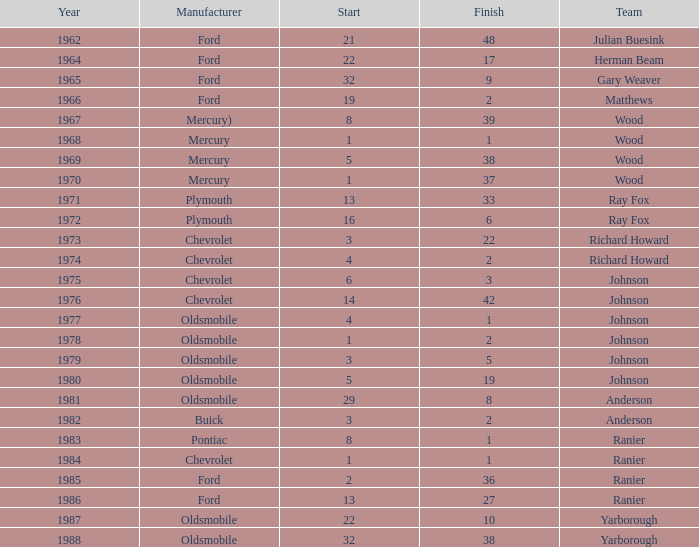What is the smallest finish time for a race after 1972 with a car manufactured by pontiac? 1.0. 